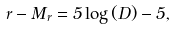Convert formula to latex. <formula><loc_0><loc_0><loc_500><loc_500>r - M _ { r } = 5 \log { ( D ) } - 5 ,</formula> 